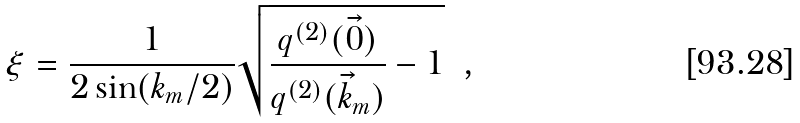<formula> <loc_0><loc_0><loc_500><loc_500>\xi = \frac { 1 } { 2 \sin ( k _ { m } / 2 ) } \sqrt { \frac { q ^ { ( 2 ) } ( \vec { 0 } ) } { q ^ { ( 2 ) } ( \vec { k } _ { m } ) } - 1 } \ \ ,</formula> 